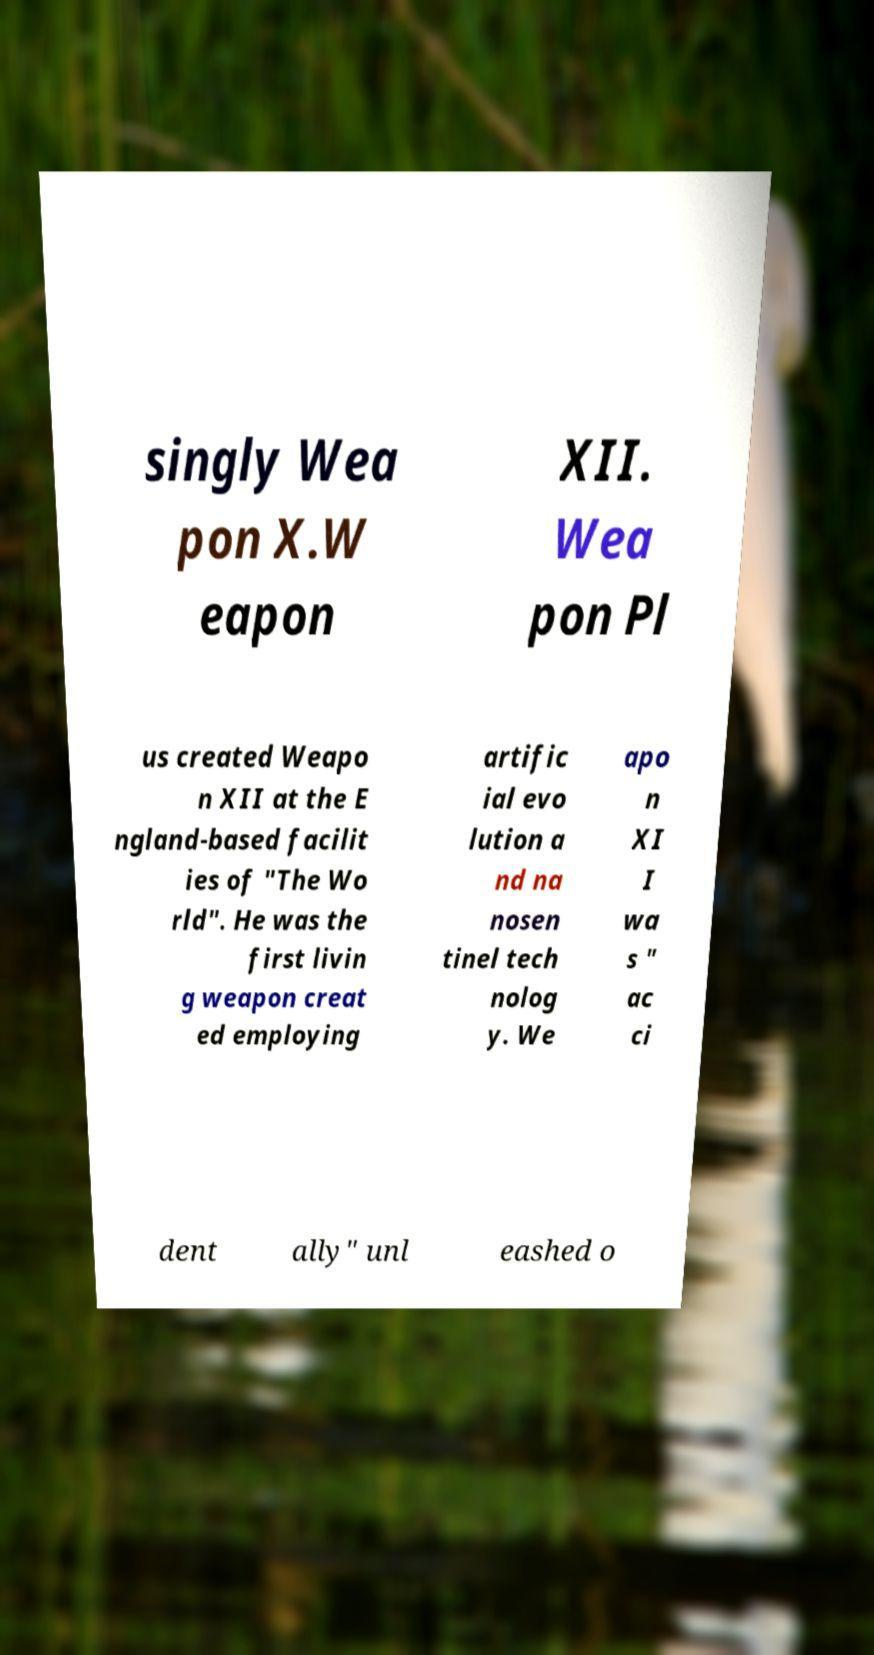Could you assist in decoding the text presented in this image and type it out clearly? singly Wea pon X.W eapon XII. Wea pon Pl us created Weapo n XII at the E ngland-based facilit ies of "The Wo rld". He was the first livin g weapon creat ed employing artific ial evo lution a nd na nosen tinel tech nolog y. We apo n XI I wa s " ac ci dent ally" unl eashed o 